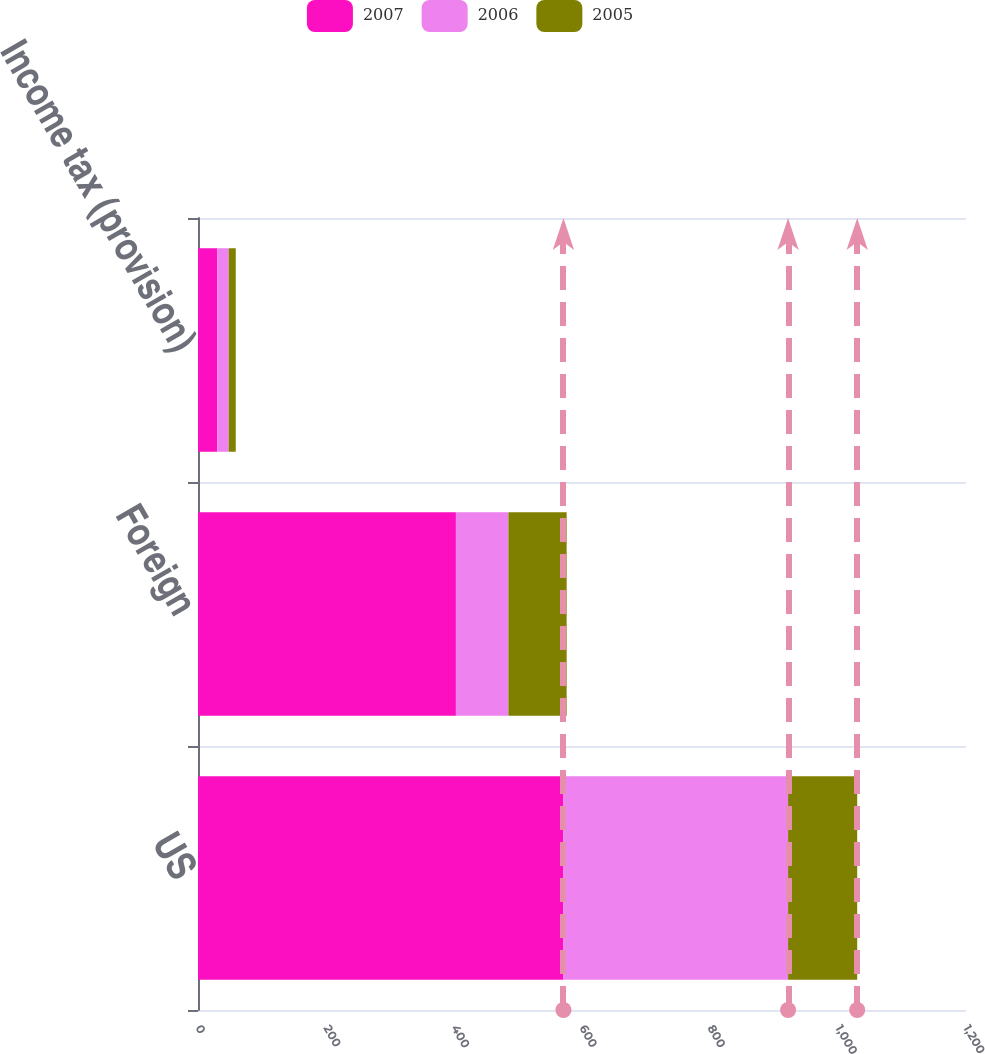Convert chart to OTSL. <chart><loc_0><loc_0><loc_500><loc_500><stacked_bar_chart><ecel><fcel>US<fcel>Foreign<fcel>Income tax (provision)<nl><fcel>2007<fcel>571<fcel>403<fcel>30<nl><fcel>2006<fcel>351<fcel>82<fcel>18<nl><fcel>2005<fcel>108<fcel>91<fcel>11<nl></chart> 